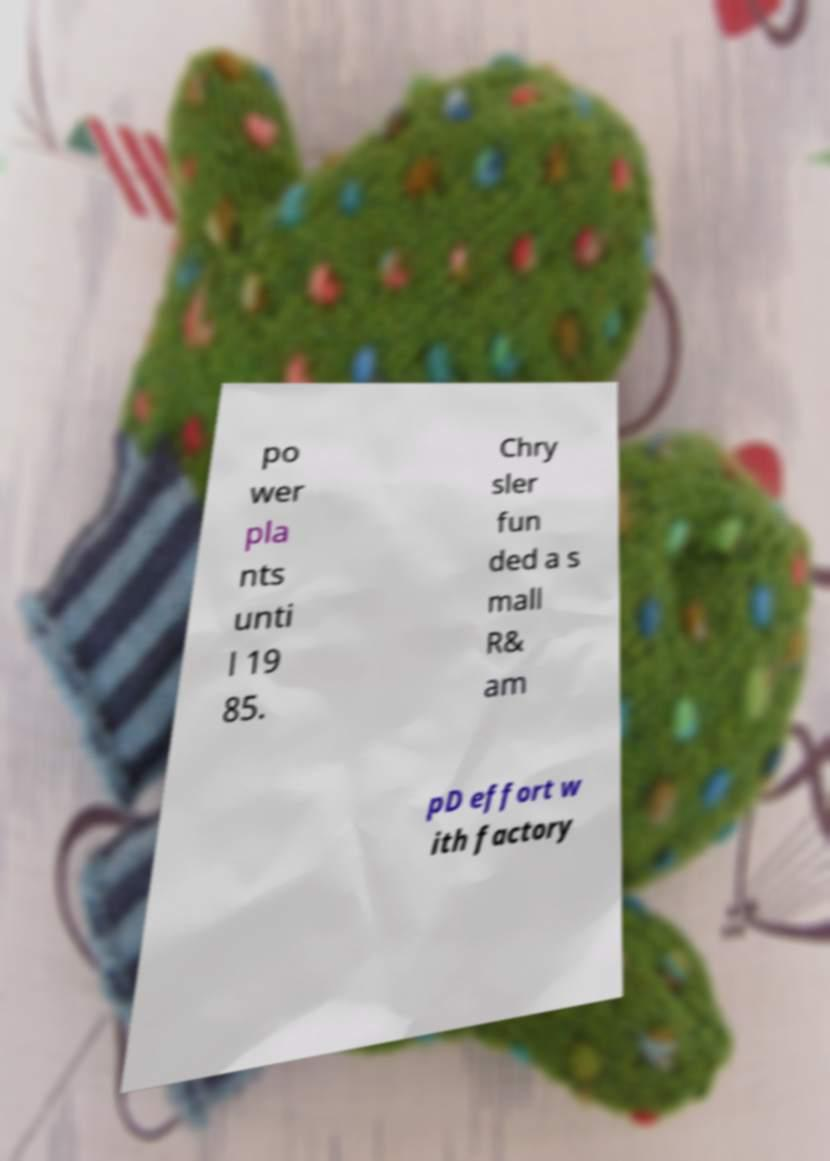For documentation purposes, I need the text within this image transcribed. Could you provide that? po wer pla nts unti l 19 85. Chry sler fun ded a s mall R& am pD effort w ith factory 